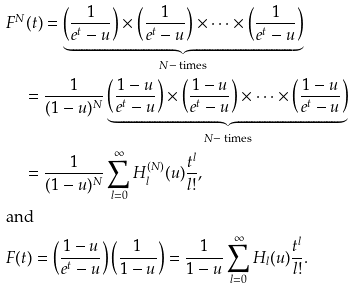<formula> <loc_0><loc_0><loc_500><loc_500>& F ^ { N } ( t ) = \underbrace { \left ( \frac { 1 } { e ^ { t } - u } \right ) \times \left ( \frac { 1 } { e ^ { t } - u } \right ) \times \cdots \times \left ( \frac { 1 } { e ^ { t } - u } \right ) } _ { N - \text { times} } \\ & \quad = \frac { 1 } { ( 1 - u ) ^ { N } } \underbrace { \left ( \frac { 1 - u } { e ^ { t } - u } \right ) \times \left ( \frac { 1 - u } { e ^ { t } - u } \right ) \times \cdots \times \left ( \frac { 1 - u } { e ^ { t } - u } \right ) } _ { N - \text { times} } \\ & \quad = \frac { 1 } { ( 1 - u ) ^ { N } } \sum _ { l = 0 } ^ { \infty } H _ { l } ^ { ( N ) } ( u ) \frac { t ^ { l } } { l ! } , \\ & \text {and} \\ & F ( t ) = \left ( \frac { 1 - u } { e ^ { t } - u } \right ) \left ( \frac { 1 } { 1 - u } \right ) = \frac { 1 } { 1 - u } \sum _ { l = 0 } ^ { \infty } H _ { l } ( u ) \frac { t ^ { l } } { l ! } .</formula> 